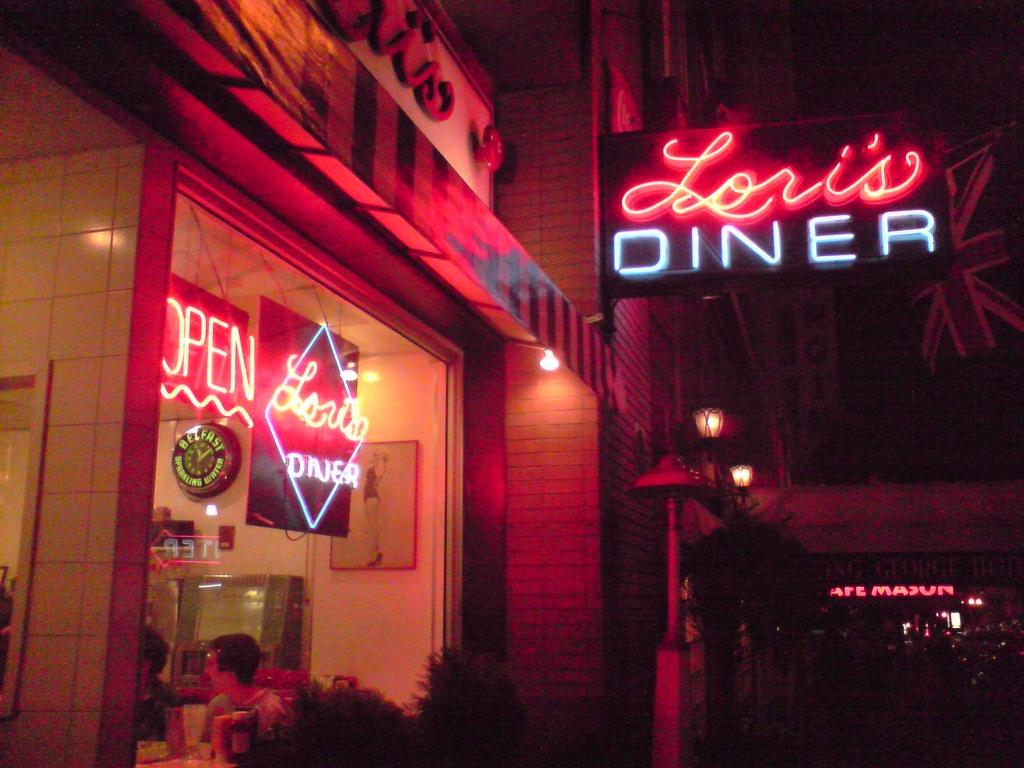<image>
Give a short and clear explanation of the subsequent image. A sign for Lori's Diner can be seen in front of a store window. 